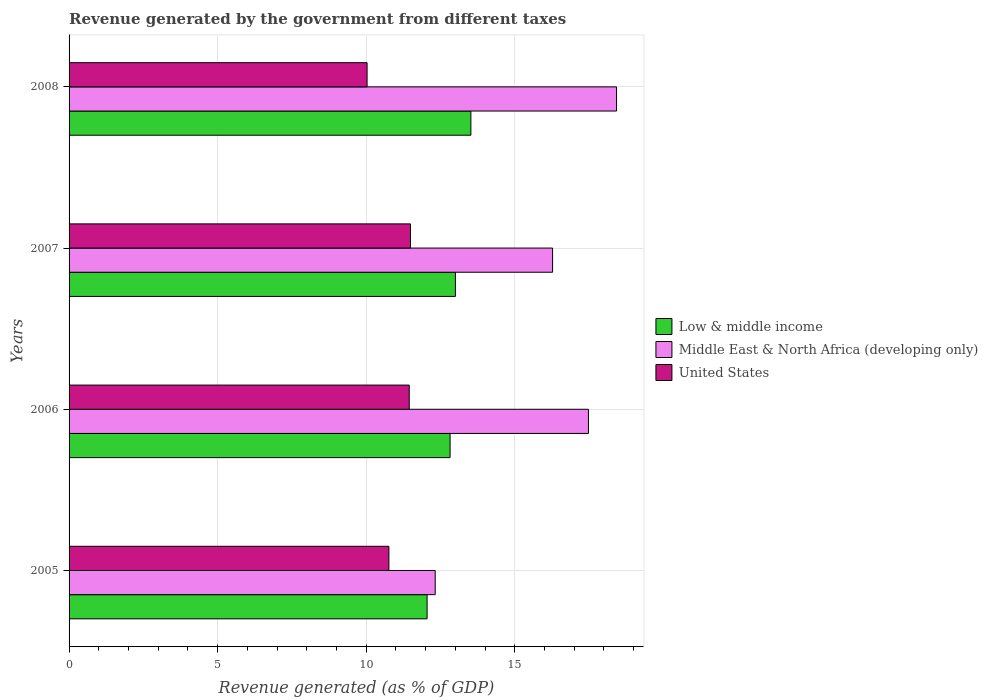Are the number of bars per tick equal to the number of legend labels?
Ensure brevity in your answer.  Yes. Are the number of bars on each tick of the Y-axis equal?
Offer a very short reply. Yes. How many bars are there on the 2nd tick from the top?
Provide a short and direct response. 3. What is the label of the 1st group of bars from the top?
Keep it short and to the point. 2008. In how many cases, is the number of bars for a given year not equal to the number of legend labels?
Provide a short and direct response. 0. What is the revenue generated by the government in Middle East & North Africa (developing only) in 2005?
Make the answer very short. 12.32. Across all years, what is the maximum revenue generated by the government in Low & middle income?
Offer a very short reply. 13.52. Across all years, what is the minimum revenue generated by the government in Middle East & North Africa (developing only)?
Your answer should be compact. 12.32. In which year was the revenue generated by the government in Middle East & North Africa (developing only) maximum?
Your response must be concise. 2008. What is the total revenue generated by the government in Middle East & North Africa (developing only) in the graph?
Offer a very short reply. 64.5. What is the difference between the revenue generated by the government in Low & middle income in 2007 and that in 2008?
Make the answer very short. -0.52. What is the difference between the revenue generated by the government in Low & middle income in 2006 and the revenue generated by the government in Middle East & North Africa (developing only) in 2008?
Provide a succinct answer. -5.6. What is the average revenue generated by the government in Low & middle income per year?
Your answer should be very brief. 12.85. In the year 2008, what is the difference between the revenue generated by the government in Middle East & North Africa (developing only) and revenue generated by the government in United States?
Offer a very short reply. 8.4. What is the ratio of the revenue generated by the government in Middle East & North Africa (developing only) in 2005 to that in 2008?
Your answer should be compact. 0.67. Is the revenue generated by the government in Low & middle income in 2005 less than that in 2007?
Your answer should be very brief. Yes. What is the difference between the highest and the second highest revenue generated by the government in Middle East & North Africa (developing only)?
Offer a very short reply. 0.95. What is the difference between the highest and the lowest revenue generated by the government in Middle East & North Africa (developing only)?
Your answer should be very brief. 6.1. Are all the bars in the graph horizontal?
Provide a succinct answer. Yes. Are the values on the major ticks of X-axis written in scientific E-notation?
Offer a terse response. No. How many legend labels are there?
Offer a very short reply. 3. What is the title of the graph?
Provide a succinct answer. Revenue generated by the government from different taxes. Does "Niger" appear as one of the legend labels in the graph?
Offer a terse response. No. What is the label or title of the X-axis?
Offer a very short reply. Revenue generated (as % of GDP). What is the Revenue generated (as % of GDP) in Low & middle income in 2005?
Give a very brief answer. 12.05. What is the Revenue generated (as % of GDP) in Middle East & North Africa (developing only) in 2005?
Offer a very short reply. 12.32. What is the Revenue generated (as % of GDP) in United States in 2005?
Give a very brief answer. 10.76. What is the Revenue generated (as % of GDP) in Low & middle income in 2006?
Your answer should be compact. 12.82. What is the Revenue generated (as % of GDP) in Middle East & North Africa (developing only) in 2006?
Your answer should be very brief. 17.48. What is the Revenue generated (as % of GDP) in United States in 2006?
Offer a terse response. 11.45. What is the Revenue generated (as % of GDP) of Low & middle income in 2007?
Your response must be concise. 13. What is the Revenue generated (as % of GDP) in Middle East & North Africa (developing only) in 2007?
Your answer should be compact. 16.27. What is the Revenue generated (as % of GDP) in United States in 2007?
Your response must be concise. 11.49. What is the Revenue generated (as % of GDP) in Low & middle income in 2008?
Your answer should be compact. 13.52. What is the Revenue generated (as % of GDP) of Middle East & North Africa (developing only) in 2008?
Give a very brief answer. 18.43. What is the Revenue generated (as % of GDP) in United States in 2008?
Ensure brevity in your answer.  10.03. Across all years, what is the maximum Revenue generated (as % of GDP) of Low & middle income?
Give a very brief answer. 13.52. Across all years, what is the maximum Revenue generated (as % of GDP) in Middle East & North Africa (developing only)?
Offer a very short reply. 18.43. Across all years, what is the maximum Revenue generated (as % of GDP) in United States?
Give a very brief answer. 11.49. Across all years, what is the minimum Revenue generated (as % of GDP) of Low & middle income?
Make the answer very short. 12.05. Across all years, what is the minimum Revenue generated (as % of GDP) in Middle East & North Africa (developing only)?
Your response must be concise. 12.32. Across all years, what is the minimum Revenue generated (as % of GDP) in United States?
Make the answer very short. 10.03. What is the total Revenue generated (as % of GDP) in Low & middle income in the graph?
Give a very brief answer. 51.4. What is the total Revenue generated (as % of GDP) of Middle East & North Africa (developing only) in the graph?
Offer a terse response. 64.5. What is the total Revenue generated (as % of GDP) of United States in the graph?
Offer a terse response. 43.73. What is the difference between the Revenue generated (as % of GDP) of Low & middle income in 2005 and that in 2006?
Offer a very short reply. -0.77. What is the difference between the Revenue generated (as % of GDP) in Middle East & North Africa (developing only) in 2005 and that in 2006?
Provide a succinct answer. -5.16. What is the difference between the Revenue generated (as % of GDP) in United States in 2005 and that in 2006?
Make the answer very short. -0.68. What is the difference between the Revenue generated (as % of GDP) in Low & middle income in 2005 and that in 2007?
Your answer should be compact. -0.95. What is the difference between the Revenue generated (as % of GDP) of Middle East & North Africa (developing only) in 2005 and that in 2007?
Make the answer very short. -3.95. What is the difference between the Revenue generated (as % of GDP) of United States in 2005 and that in 2007?
Your answer should be very brief. -0.73. What is the difference between the Revenue generated (as % of GDP) of Low & middle income in 2005 and that in 2008?
Make the answer very short. -1.47. What is the difference between the Revenue generated (as % of GDP) of Middle East & North Africa (developing only) in 2005 and that in 2008?
Provide a short and direct response. -6.1. What is the difference between the Revenue generated (as % of GDP) in United States in 2005 and that in 2008?
Your answer should be compact. 0.73. What is the difference between the Revenue generated (as % of GDP) of Low & middle income in 2006 and that in 2007?
Give a very brief answer. -0.18. What is the difference between the Revenue generated (as % of GDP) of Middle East & North Africa (developing only) in 2006 and that in 2007?
Provide a succinct answer. 1.21. What is the difference between the Revenue generated (as % of GDP) in United States in 2006 and that in 2007?
Provide a short and direct response. -0.04. What is the difference between the Revenue generated (as % of GDP) in Low & middle income in 2006 and that in 2008?
Make the answer very short. -0.7. What is the difference between the Revenue generated (as % of GDP) of Middle East & North Africa (developing only) in 2006 and that in 2008?
Offer a very short reply. -0.95. What is the difference between the Revenue generated (as % of GDP) in United States in 2006 and that in 2008?
Offer a terse response. 1.42. What is the difference between the Revenue generated (as % of GDP) in Low & middle income in 2007 and that in 2008?
Offer a very short reply. -0.52. What is the difference between the Revenue generated (as % of GDP) in Middle East & North Africa (developing only) in 2007 and that in 2008?
Ensure brevity in your answer.  -2.15. What is the difference between the Revenue generated (as % of GDP) in United States in 2007 and that in 2008?
Ensure brevity in your answer.  1.46. What is the difference between the Revenue generated (as % of GDP) in Low & middle income in 2005 and the Revenue generated (as % of GDP) in Middle East & North Africa (developing only) in 2006?
Your answer should be compact. -5.43. What is the difference between the Revenue generated (as % of GDP) in Low & middle income in 2005 and the Revenue generated (as % of GDP) in United States in 2006?
Your answer should be compact. 0.6. What is the difference between the Revenue generated (as % of GDP) of Middle East & North Africa (developing only) in 2005 and the Revenue generated (as % of GDP) of United States in 2006?
Keep it short and to the point. 0.87. What is the difference between the Revenue generated (as % of GDP) of Low & middle income in 2005 and the Revenue generated (as % of GDP) of Middle East & North Africa (developing only) in 2007?
Your response must be concise. -4.22. What is the difference between the Revenue generated (as % of GDP) in Low & middle income in 2005 and the Revenue generated (as % of GDP) in United States in 2007?
Provide a succinct answer. 0.56. What is the difference between the Revenue generated (as % of GDP) of Middle East & North Africa (developing only) in 2005 and the Revenue generated (as % of GDP) of United States in 2007?
Provide a short and direct response. 0.83. What is the difference between the Revenue generated (as % of GDP) in Low & middle income in 2005 and the Revenue generated (as % of GDP) in Middle East & North Africa (developing only) in 2008?
Ensure brevity in your answer.  -6.38. What is the difference between the Revenue generated (as % of GDP) in Low & middle income in 2005 and the Revenue generated (as % of GDP) in United States in 2008?
Offer a very short reply. 2.02. What is the difference between the Revenue generated (as % of GDP) of Middle East & North Africa (developing only) in 2005 and the Revenue generated (as % of GDP) of United States in 2008?
Provide a short and direct response. 2.29. What is the difference between the Revenue generated (as % of GDP) of Low & middle income in 2006 and the Revenue generated (as % of GDP) of Middle East & North Africa (developing only) in 2007?
Provide a succinct answer. -3.45. What is the difference between the Revenue generated (as % of GDP) of Low & middle income in 2006 and the Revenue generated (as % of GDP) of United States in 2007?
Offer a very short reply. 1.33. What is the difference between the Revenue generated (as % of GDP) in Middle East & North Africa (developing only) in 2006 and the Revenue generated (as % of GDP) in United States in 2007?
Ensure brevity in your answer.  5.99. What is the difference between the Revenue generated (as % of GDP) of Low & middle income in 2006 and the Revenue generated (as % of GDP) of Middle East & North Africa (developing only) in 2008?
Give a very brief answer. -5.6. What is the difference between the Revenue generated (as % of GDP) of Low & middle income in 2006 and the Revenue generated (as % of GDP) of United States in 2008?
Ensure brevity in your answer.  2.79. What is the difference between the Revenue generated (as % of GDP) of Middle East & North Africa (developing only) in 2006 and the Revenue generated (as % of GDP) of United States in 2008?
Provide a succinct answer. 7.45. What is the difference between the Revenue generated (as % of GDP) in Low & middle income in 2007 and the Revenue generated (as % of GDP) in Middle East & North Africa (developing only) in 2008?
Your answer should be very brief. -5.42. What is the difference between the Revenue generated (as % of GDP) of Low & middle income in 2007 and the Revenue generated (as % of GDP) of United States in 2008?
Offer a terse response. 2.97. What is the difference between the Revenue generated (as % of GDP) of Middle East & North Africa (developing only) in 2007 and the Revenue generated (as % of GDP) of United States in 2008?
Make the answer very short. 6.24. What is the average Revenue generated (as % of GDP) in Low & middle income per year?
Offer a terse response. 12.85. What is the average Revenue generated (as % of GDP) in Middle East & North Africa (developing only) per year?
Your answer should be compact. 16.13. What is the average Revenue generated (as % of GDP) of United States per year?
Your answer should be very brief. 10.93. In the year 2005, what is the difference between the Revenue generated (as % of GDP) of Low & middle income and Revenue generated (as % of GDP) of Middle East & North Africa (developing only)?
Ensure brevity in your answer.  -0.27. In the year 2005, what is the difference between the Revenue generated (as % of GDP) of Middle East & North Africa (developing only) and Revenue generated (as % of GDP) of United States?
Offer a terse response. 1.56. In the year 2006, what is the difference between the Revenue generated (as % of GDP) of Low & middle income and Revenue generated (as % of GDP) of Middle East & North Africa (developing only)?
Offer a very short reply. -4.66. In the year 2006, what is the difference between the Revenue generated (as % of GDP) of Low & middle income and Revenue generated (as % of GDP) of United States?
Ensure brevity in your answer.  1.38. In the year 2006, what is the difference between the Revenue generated (as % of GDP) of Middle East & North Africa (developing only) and Revenue generated (as % of GDP) of United States?
Provide a short and direct response. 6.03. In the year 2007, what is the difference between the Revenue generated (as % of GDP) of Low & middle income and Revenue generated (as % of GDP) of Middle East & North Africa (developing only)?
Your response must be concise. -3.27. In the year 2007, what is the difference between the Revenue generated (as % of GDP) of Low & middle income and Revenue generated (as % of GDP) of United States?
Your answer should be very brief. 1.51. In the year 2007, what is the difference between the Revenue generated (as % of GDP) of Middle East & North Africa (developing only) and Revenue generated (as % of GDP) of United States?
Your answer should be compact. 4.78. In the year 2008, what is the difference between the Revenue generated (as % of GDP) of Low & middle income and Revenue generated (as % of GDP) of Middle East & North Africa (developing only)?
Make the answer very short. -4.9. In the year 2008, what is the difference between the Revenue generated (as % of GDP) of Low & middle income and Revenue generated (as % of GDP) of United States?
Give a very brief answer. 3.49. In the year 2008, what is the difference between the Revenue generated (as % of GDP) in Middle East & North Africa (developing only) and Revenue generated (as % of GDP) in United States?
Your response must be concise. 8.4. What is the ratio of the Revenue generated (as % of GDP) in Low & middle income in 2005 to that in 2006?
Keep it short and to the point. 0.94. What is the ratio of the Revenue generated (as % of GDP) in Middle East & North Africa (developing only) in 2005 to that in 2006?
Offer a terse response. 0.7. What is the ratio of the Revenue generated (as % of GDP) in United States in 2005 to that in 2006?
Your answer should be compact. 0.94. What is the ratio of the Revenue generated (as % of GDP) in Low & middle income in 2005 to that in 2007?
Offer a very short reply. 0.93. What is the ratio of the Revenue generated (as % of GDP) of Middle East & North Africa (developing only) in 2005 to that in 2007?
Keep it short and to the point. 0.76. What is the ratio of the Revenue generated (as % of GDP) of United States in 2005 to that in 2007?
Ensure brevity in your answer.  0.94. What is the ratio of the Revenue generated (as % of GDP) in Low & middle income in 2005 to that in 2008?
Your answer should be very brief. 0.89. What is the ratio of the Revenue generated (as % of GDP) of Middle East & North Africa (developing only) in 2005 to that in 2008?
Offer a terse response. 0.67. What is the ratio of the Revenue generated (as % of GDP) in United States in 2005 to that in 2008?
Offer a very short reply. 1.07. What is the ratio of the Revenue generated (as % of GDP) of Low & middle income in 2006 to that in 2007?
Keep it short and to the point. 0.99. What is the ratio of the Revenue generated (as % of GDP) in Middle East & North Africa (developing only) in 2006 to that in 2007?
Offer a terse response. 1.07. What is the ratio of the Revenue generated (as % of GDP) of Low & middle income in 2006 to that in 2008?
Make the answer very short. 0.95. What is the ratio of the Revenue generated (as % of GDP) of Middle East & North Africa (developing only) in 2006 to that in 2008?
Your response must be concise. 0.95. What is the ratio of the Revenue generated (as % of GDP) in United States in 2006 to that in 2008?
Provide a short and direct response. 1.14. What is the ratio of the Revenue generated (as % of GDP) in Low & middle income in 2007 to that in 2008?
Your answer should be very brief. 0.96. What is the ratio of the Revenue generated (as % of GDP) of Middle East & North Africa (developing only) in 2007 to that in 2008?
Your answer should be compact. 0.88. What is the ratio of the Revenue generated (as % of GDP) in United States in 2007 to that in 2008?
Offer a very short reply. 1.15. What is the difference between the highest and the second highest Revenue generated (as % of GDP) in Low & middle income?
Your answer should be compact. 0.52. What is the difference between the highest and the second highest Revenue generated (as % of GDP) in Middle East & North Africa (developing only)?
Make the answer very short. 0.95. What is the difference between the highest and the second highest Revenue generated (as % of GDP) of United States?
Offer a very short reply. 0.04. What is the difference between the highest and the lowest Revenue generated (as % of GDP) of Low & middle income?
Your answer should be very brief. 1.47. What is the difference between the highest and the lowest Revenue generated (as % of GDP) in Middle East & North Africa (developing only)?
Provide a short and direct response. 6.1. What is the difference between the highest and the lowest Revenue generated (as % of GDP) of United States?
Offer a very short reply. 1.46. 